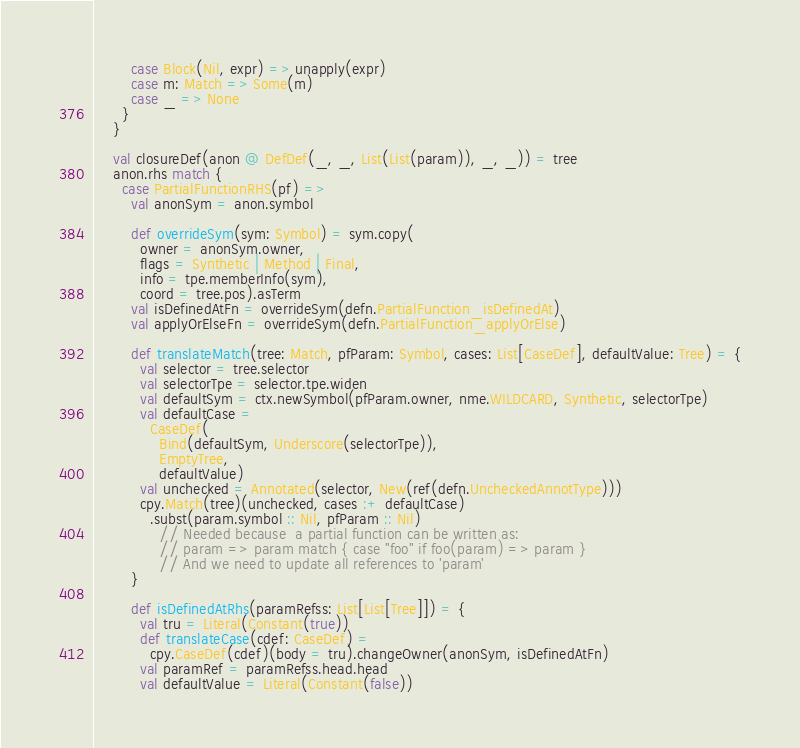Convert code to text. <code><loc_0><loc_0><loc_500><loc_500><_Scala_>        case Block(Nil, expr) => unapply(expr)
        case m: Match => Some(m)
        case _ => None
      }
    }

    val closureDef(anon @ DefDef(_, _, List(List(param)), _, _)) = tree
    anon.rhs match {
      case PartialFunctionRHS(pf) =>
        val anonSym = anon.symbol

        def overrideSym(sym: Symbol) = sym.copy(
          owner = anonSym.owner,
          flags = Synthetic | Method | Final,
          info = tpe.memberInfo(sym),
          coord = tree.pos).asTerm
        val isDefinedAtFn = overrideSym(defn.PartialFunction_isDefinedAt)
        val applyOrElseFn = overrideSym(defn.PartialFunction_applyOrElse)

        def translateMatch(tree: Match, pfParam: Symbol, cases: List[CaseDef], defaultValue: Tree) = {
          val selector = tree.selector
          val selectorTpe = selector.tpe.widen
          val defaultSym = ctx.newSymbol(pfParam.owner, nme.WILDCARD, Synthetic, selectorTpe)
          val defaultCase =
            CaseDef(
              Bind(defaultSym, Underscore(selectorTpe)),
              EmptyTree,
              defaultValue)
          val unchecked = Annotated(selector, New(ref(defn.UncheckedAnnotType)))
          cpy.Match(tree)(unchecked, cases :+ defaultCase)
            .subst(param.symbol :: Nil, pfParam :: Nil)
              // Needed because  a partial function can be written as:
              // param => param match { case "foo" if foo(param) => param }
              // And we need to update all references to 'param'
        }

        def isDefinedAtRhs(paramRefss: List[List[Tree]]) = {
          val tru = Literal(Constant(true))
          def translateCase(cdef: CaseDef) =
            cpy.CaseDef(cdef)(body = tru).changeOwner(anonSym, isDefinedAtFn)
          val paramRef = paramRefss.head.head
          val defaultValue = Literal(Constant(false))</code> 